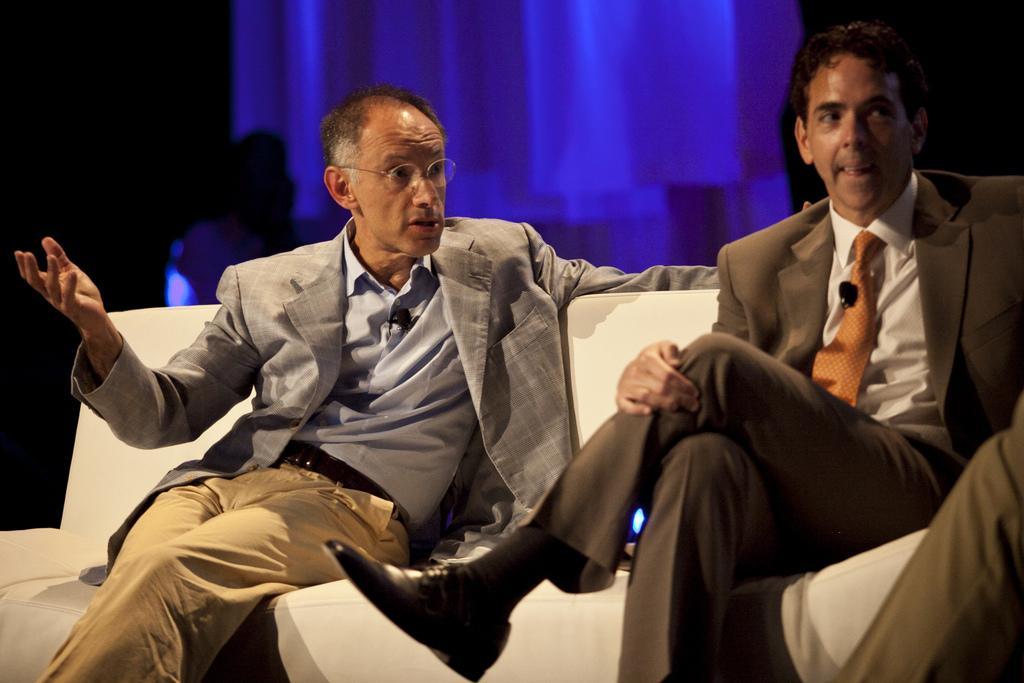How many people are in the image? There are two persons in the image. What are the persons wearing? The persons are wearing coats. Where are the persons sitting? The persons are sitting on a white color sofa. What is the color of the sofa? The sofa is white. How would you describe the background of the image? The background of the image is dark, and blue color lights are visible. Can you see any bubbles in the image? There are no bubbles present in the image. Is there a frog sitting on the sofa with the persons? There is no frog present in the image. 